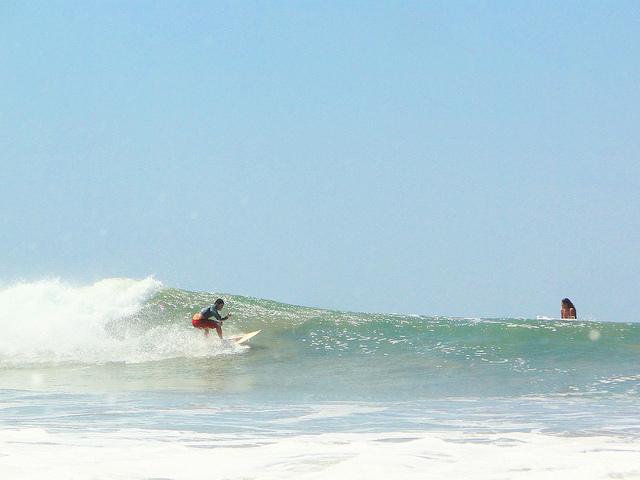What is the man doing in the picture?
Concise answer only. Surfing. Are there clouds in the sky over the water?
Answer briefly. No. Is there a wave in the water?
Quick response, please. Yes. 